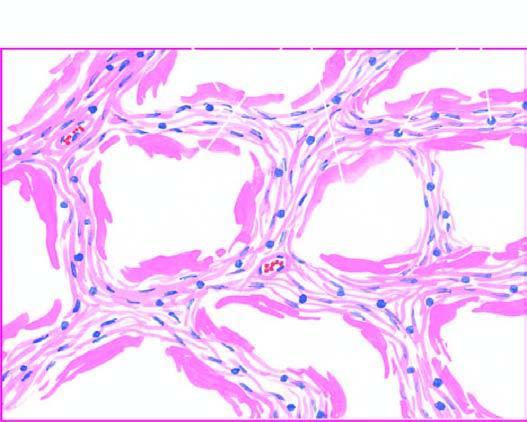re there alternate areas of collapsed and dilated alveolar spaces, many of which are lined by eosinophilic hyaline membranes?
Answer the question using a single word or phrase. Yes 